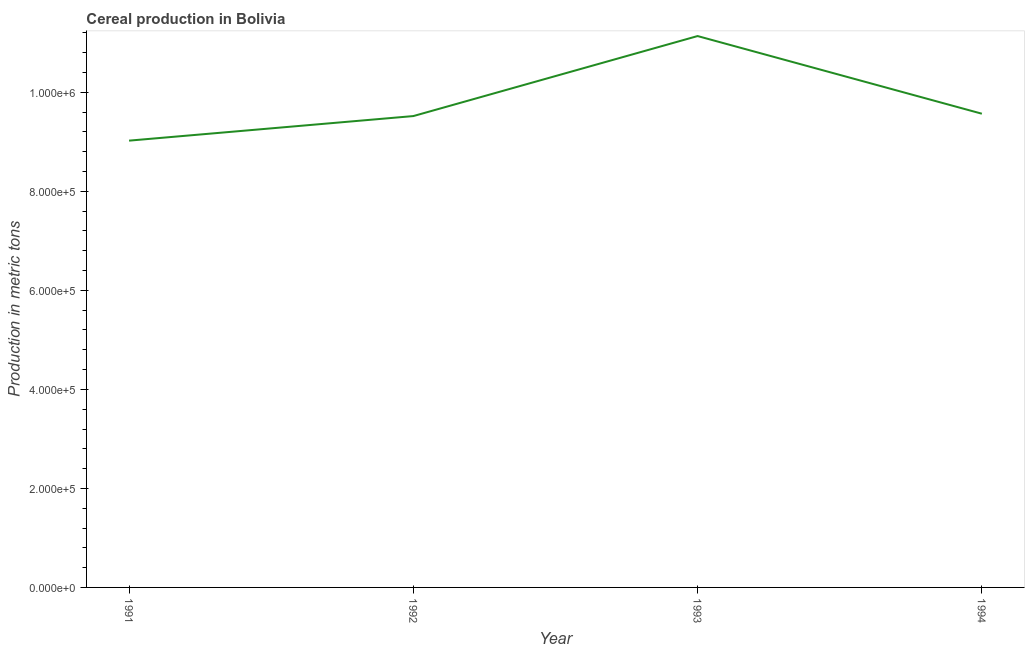What is the cereal production in 1992?
Ensure brevity in your answer.  9.52e+05. Across all years, what is the maximum cereal production?
Your answer should be very brief. 1.11e+06. Across all years, what is the minimum cereal production?
Give a very brief answer. 9.02e+05. In which year was the cereal production maximum?
Ensure brevity in your answer.  1993. In which year was the cereal production minimum?
Your answer should be very brief. 1991. What is the sum of the cereal production?
Your answer should be compact. 3.93e+06. What is the difference between the cereal production in 1992 and 1994?
Provide a succinct answer. -4762. What is the average cereal production per year?
Offer a very short reply. 9.81e+05. What is the median cereal production?
Keep it short and to the point. 9.55e+05. Do a majority of the years between 1991 and 1992 (inclusive) have cereal production greater than 200000 metric tons?
Your answer should be compact. Yes. What is the ratio of the cereal production in 1991 to that in 1993?
Provide a short and direct response. 0.81. Is the difference between the cereal production in 1993 and 1994 greater than the difference between any two years?
Provide a succinct answer. No. What is the difference between the highest and the second highest cereal production?
Make the answer very short. 1.57e+05. What is the difference between the highest and the lowest cereal production?
Ensure brevity in your answer.  2.11e+05. In how many years, is the cereal production greater than the average cereal production taken over all years?
Offer a terse response. 1. Does the cereal production monotonically increase over the years?
Provide a succinct answer. No. How many lines are there?
Your response must be concise. 1. Are the values on the major ticks of Y-axis written in scientific E-notation?
Offer a very short reply. Yes. Does the graph contain any zero values?
Give a very brief answer. No. Does the graph contain grids?
Keep it short and to the point. No. What is the title of the graph?
Ensure brevity in your answer.  Cereal production in Bolivia. What is the label or title of the Y-axis?
Provide a short and direct response. Production in metric tons. What is the Production in metric tons in 1991?
Provide a succinct answer. 9.02e+05. What is the Production in metric tons in 1992?
Keep it short and to the point. 9.52e+05. What is the Production in metric tons of 1993?
Make the answer very short. 1.11e+06. What is the Production in metric tons in 1994?
Offer a terse response. 9.57e+05. What is the difference between the Production in metric tons in 1991 and 1992?
Offer a very short reply. -4.96e+04. What is the difference between the Production in metric tons in 1991 and 1993?
Offer a very short reply. -2.11e+05. What is the difference between the Production in metric tons in 1991 and 1994?
Give a very brief answer. -5.44e+04. What is the difference between the Production in metric tons in 1992 and 1993?
Keep it short and to the point. -1.62e+05. What is the difference between the Production in metric tons in 1992 and 1994?
Offer a terse response. -4762. What is the difference between the Production in metric tons in 1993 and 1994?
Ensure brevity in your answer.  1.57e+05. What is the ratio of the Production in metric tons in 1991 to that in 1992?
Provide a short and direct response. 0.95. What is the ratio of the Production in metric tons in 1991 to that in 1993?
Provide a short and direct response. 0.81. What is the ratio of the Production in metric tons in 1991 to that in 1994?
Your answer should be very brief. 0.94. What is the ratio of the Production in metric tons in 1992 to that in 1993?
Keep it short and to the point. 0.85. What is the ratio of the Production in metric tons in 1993 to that in 1994?
Make the answer very short. 1.16. 